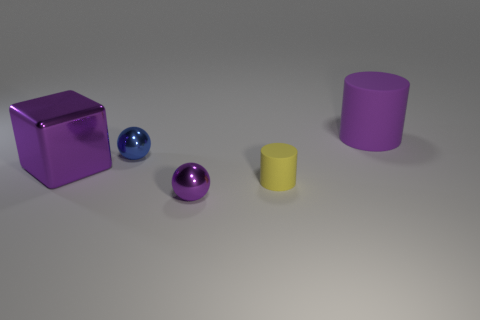Add 4 small metal spheres. How many objects exist? 9 Subtract all balls. How many objects are left? 3 Subtract 0 cyan cylinders. How many objects are left? 5 Subtract all small purple rubber things. Subtract all big purple cubes. How many objects are left? 4 Add 5 yellow things. How many yellow things are left? 6 Add 2 big green cubes. How many big green cubes exist? 2 